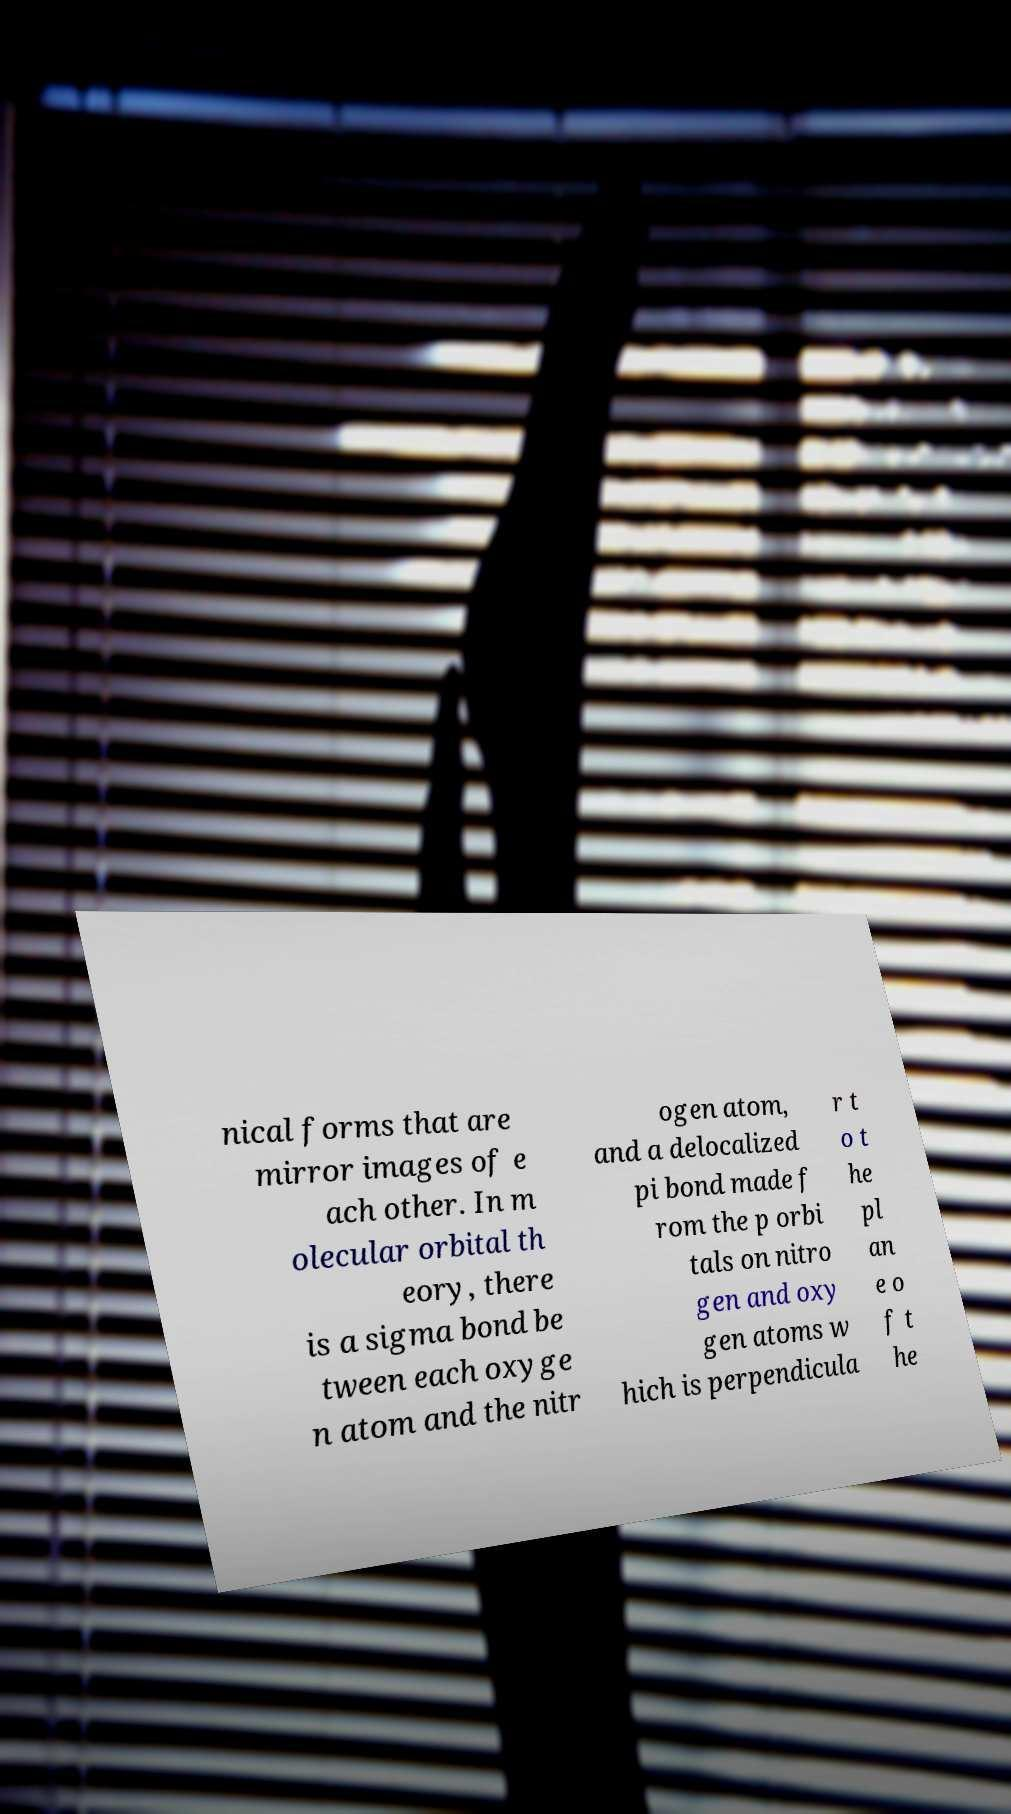Could you assist in decoding the text presented in this image and type it out clearly? nical forms that are mirror images of e ach other. In m olecular orbital th eory, there is a sigma bond be tween each oxyge n atom and the nitr ogen atom, and a delocalized pi bond made f rom the p orbi tals on nitro gen and oxy gen atoms w hich is perpendicula r t o t he pl an e o f t he 